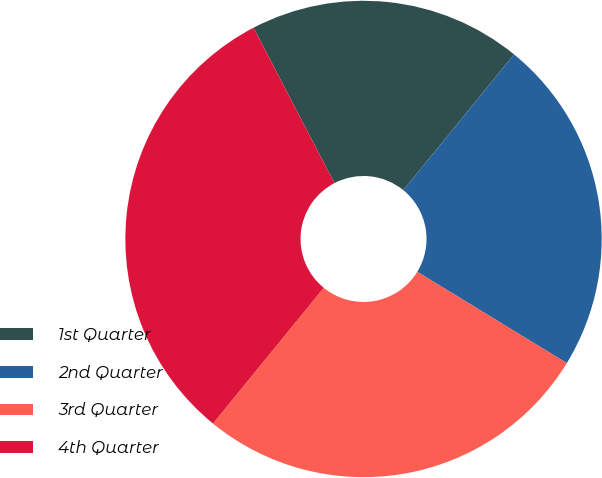Convert chart to OTSL. <chart><loc_0><loc_0><loc_500><loc_500><pie_chart><fcel>1st Quarter<fcel>2nd Quarter<fcel>3rd Quarter<fcel>4th Quarter<nl><fcel>18.53%<fcel>22.84%<fcel>27.16%<fcel>31.47%<nl></chart> 